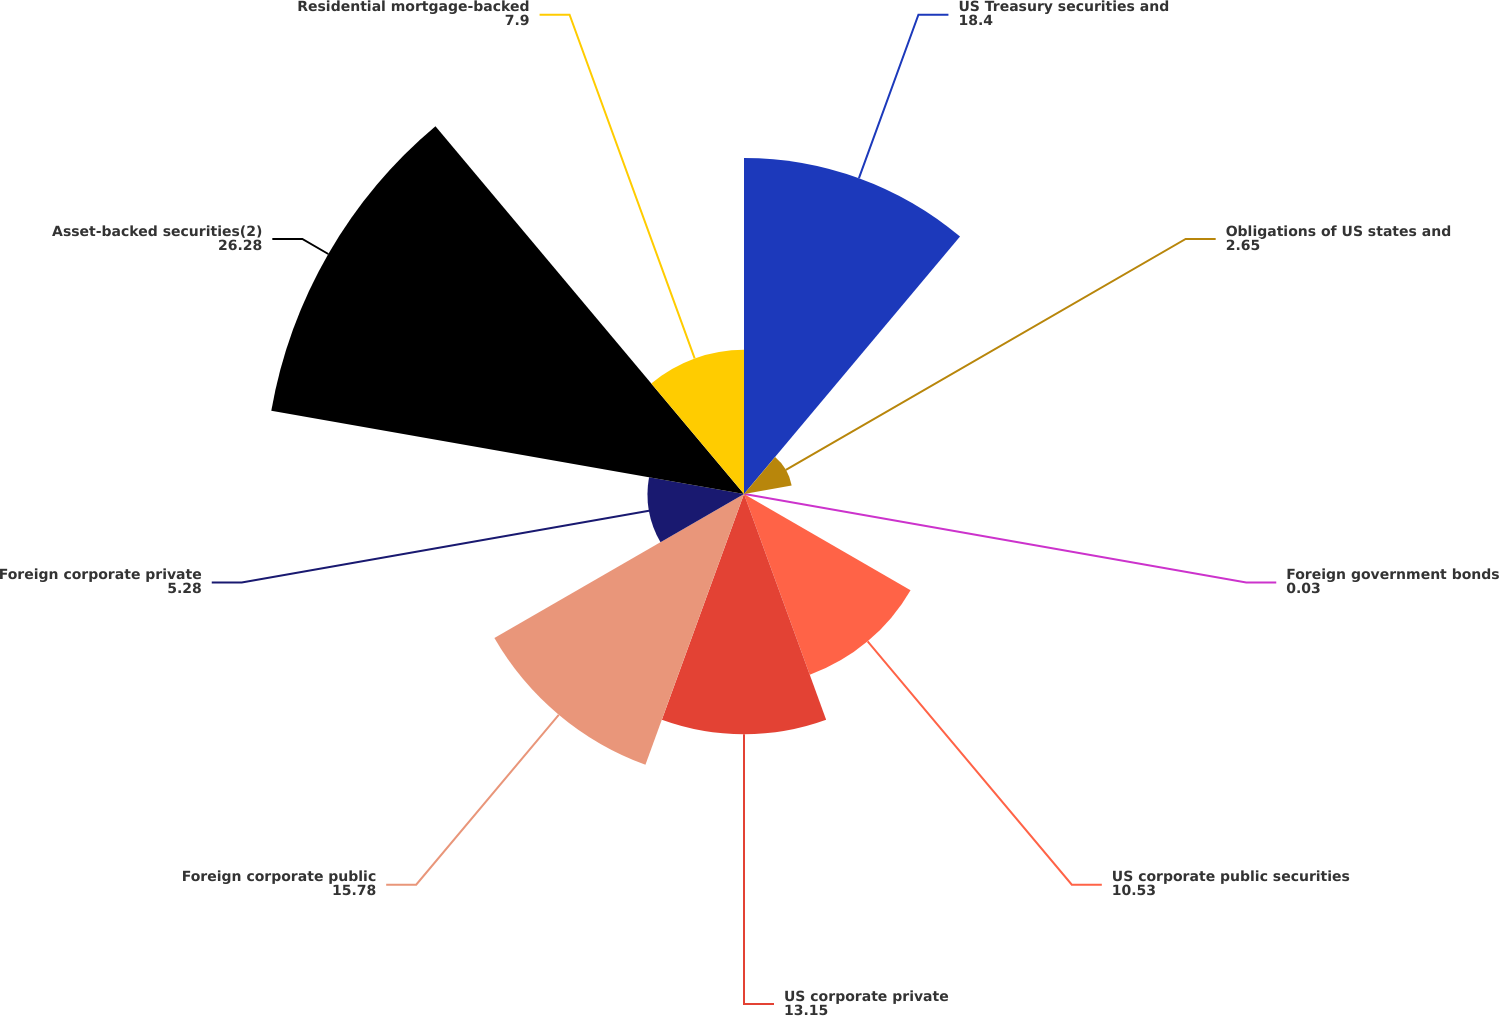<chart> <loc_0><loc_0><loc_500><loc_500><pie_chart><fcel>US Treasury securities and<fcel>Obligations of US states and<fcel>Foreign government bonds<fcel>US corporate public securities<fcel>US corporate private<fcel>Foreign corporate public<fcel>Foreign corporate private<fcel>Asset-backed securities(2)<fcel>Residential mortgage-backed<nl><fcel>18.4%<fcel>2.65%<fcel>0.03%<fcel>10.53%<fcel>13.15%<fcel>15.78%<fcel>5.28%<fcel>26.28%<fcel>7.9%<nl></chart> 